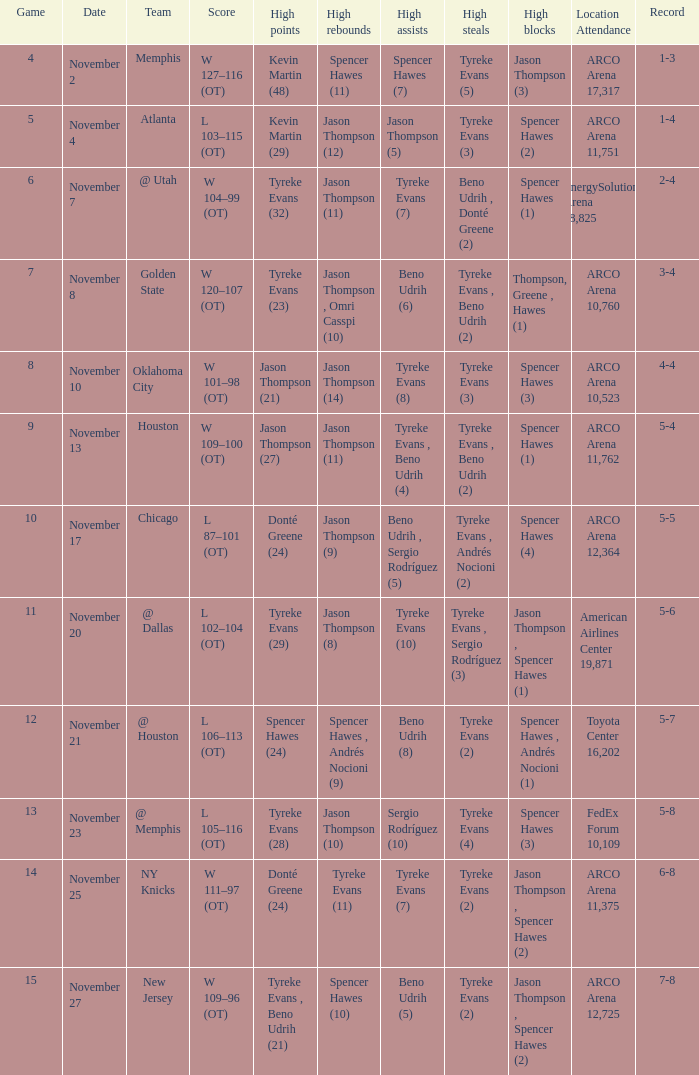If the record is 5-5, what is the game maximum? 10.0. 